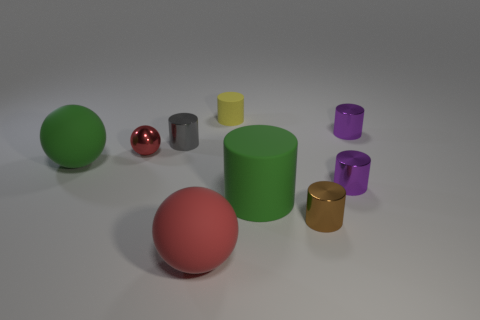Subtract all big spheres. How many spheres are left? 1 Add 1 brown cylinders. How many objects exist? 10 Subtract all gray cylinders. How many cylinders are left? 5 Subtract 2 balls. How many balls are left? 1 Subtract all cylinders. How many objects are left? 3 Subtract all purple cylinders. Subtract all yellow blocks. How many cylinders are left? 4 Subtract all purple cylinders. How many red spheres are left? 2 Subtract all large cyan matte balls. Subtract all cylinders. How many objects are left? 3 Add 3 small gray objects. How many small gray objects are left? 4 Add 6 tiny blue cylinders. How many tiny blue cylinders exist? 6 